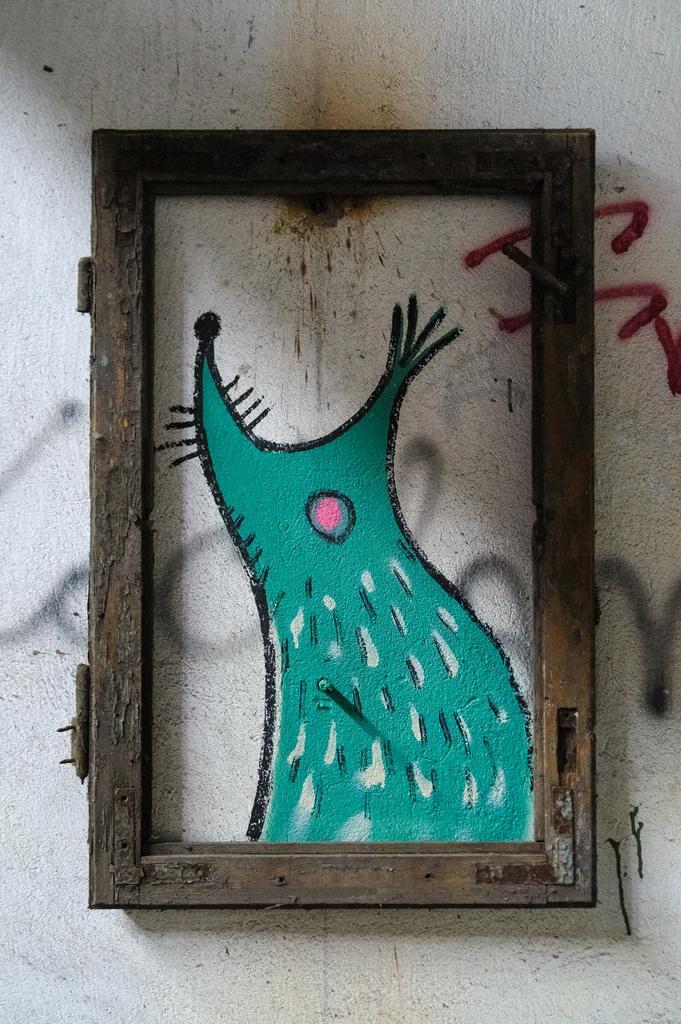How would you summarize this image in a sentence or two? In this picture, it looks like a frame. Inside the frame, there is a painting on the wall. 